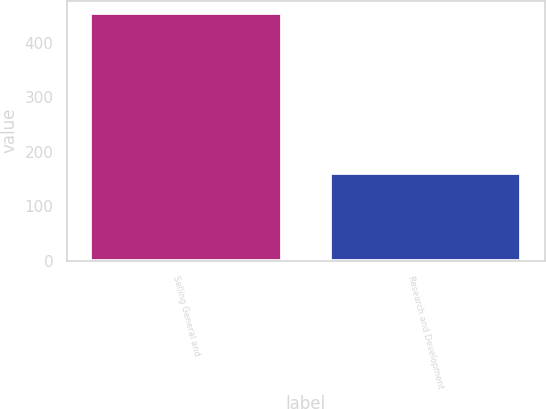<chart> <loc_0><loc_0><loc_500><loc_500><bar_chart><fcel>Selling General and<fcel>Research and Development<nl><fcel>454<fcel>162<nl></chart> 